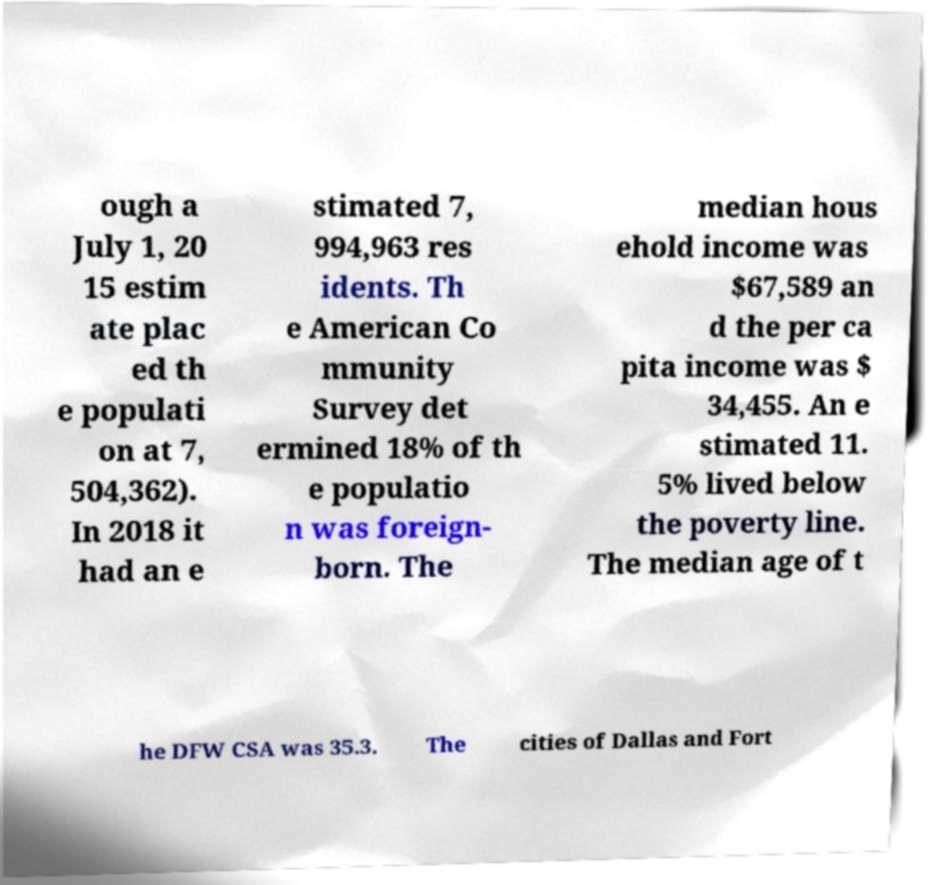Please identify and transcribe the text found in this image. ough a July 1, 20 15 estim ate plac ed th e populati on at 7, 504,362). In 2018 it had an e stimated 7, 994,963 res idents. Th e American Co mmunity Survey det ermined 18% of th e populatio n was foreign- born. The median hous ehold income was $67,589 an d the per ca pita income was $ 34,455. An e stimated 11. 5% lived below the poverty line. The median age of t he DFW CSA was 35.3. The cities of Dallas and Fort 